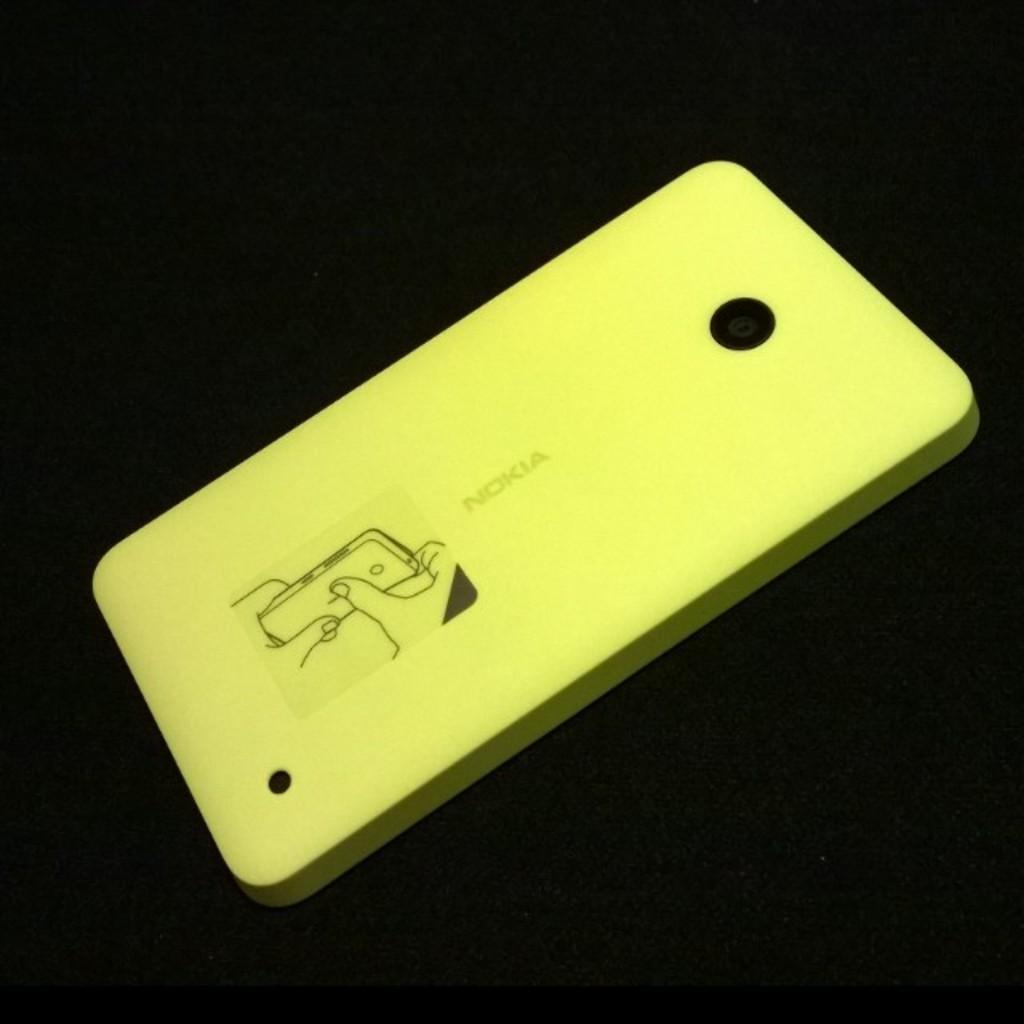What is the brand of this phone?
Make the answer very short. Nokia. 